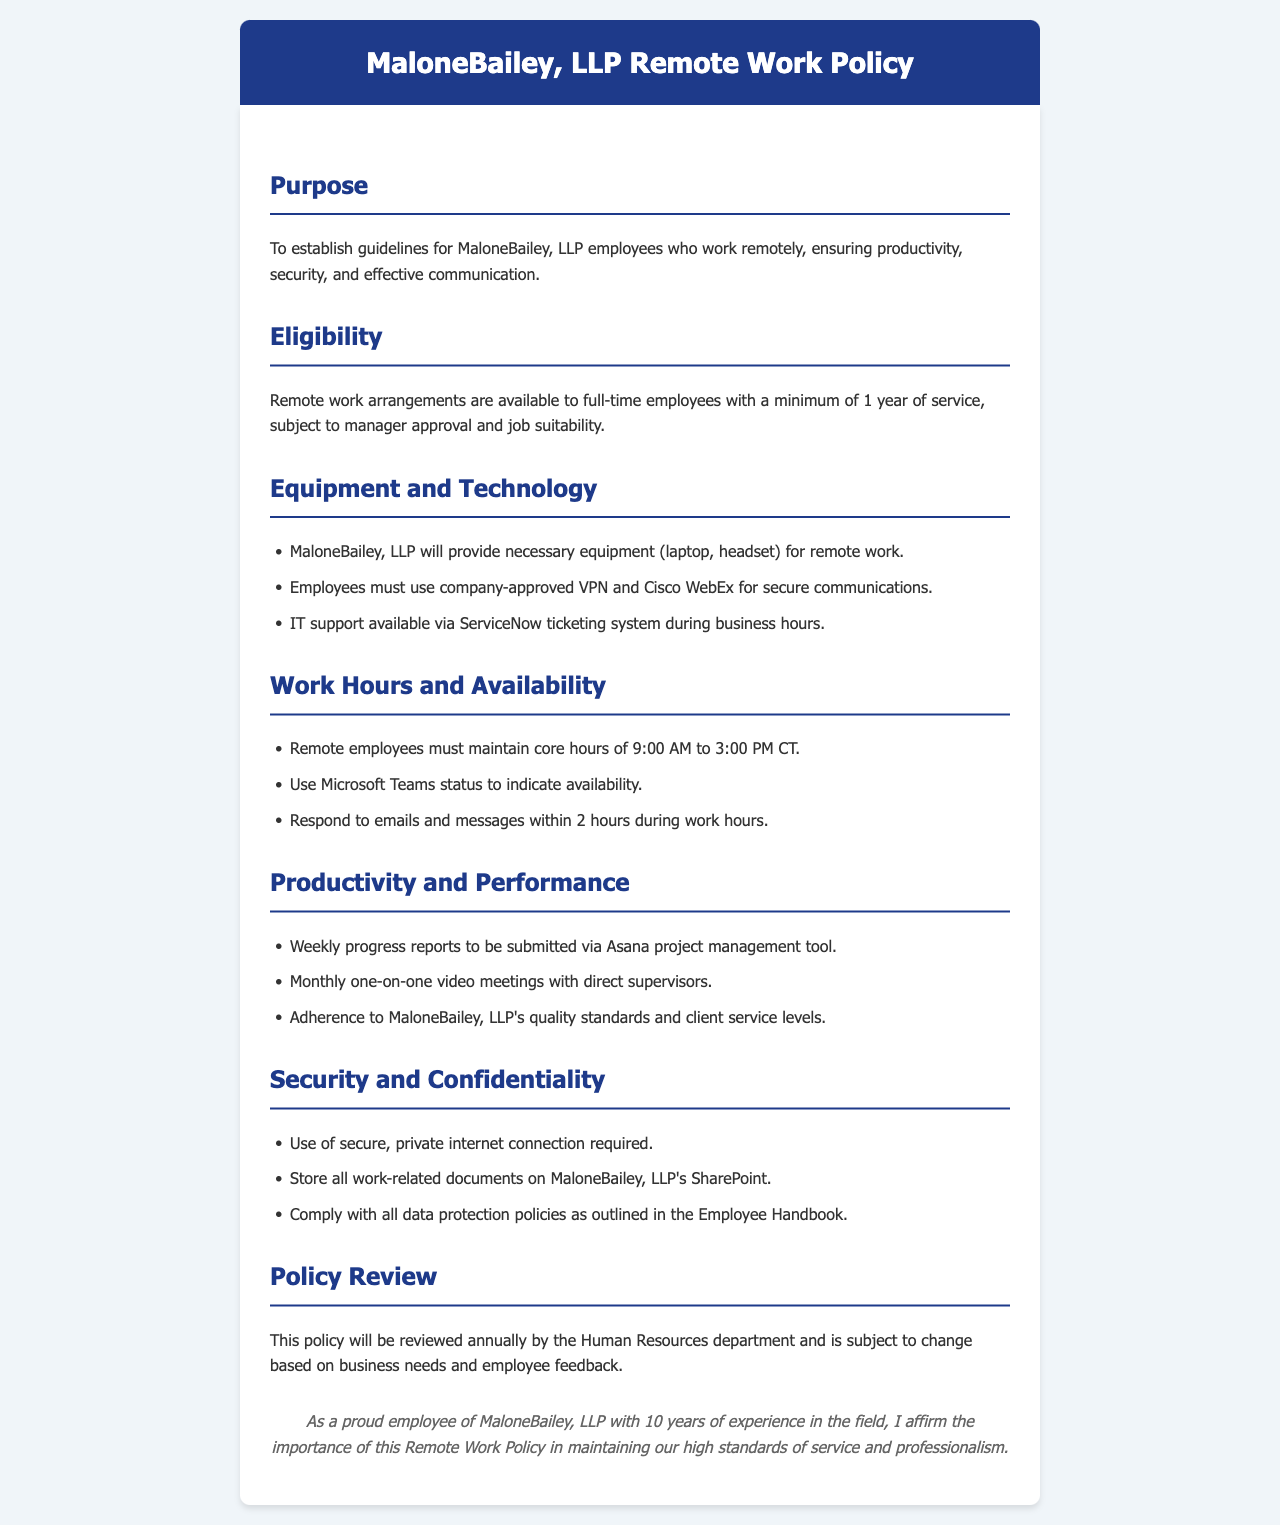What is the minimum service requirement for remote work eligibility? The document states that remote work arrangements are available to full-time employees with a minimum of 1 year of service.
Answer: 1 year Which tools are mentioned for secure communications? The document lists the use of company-approved VPN and Cisco WebEx for secure communications.
Answer: VPN and Cisco WebEx What is the required response time for emails during work hours? The document specifies that employees must respond to emails and messages within 2 hours during work hours.
Answer: 2 hours What must remote employees maintain during core hours? The document indicates that remote employees must maintain availability during core hours of 9:00 AM to 3:00 PM CT.
Answer: Availability How often are progress reports to be submitted? According to the document, weekly progress reports are to be submitted via the Asana project management tool.
Answer: Weekly What is the frequency of one-on-one video meetings with supervisors? The document states that there are monthly one-on-one video meetings with direct supervisors.
Answer: Monthly Where should work-related documents be stored? The document specifies that all work-related documents should be stored on MaloneBailey, LLP's SharePoint.
Answer: SharePoint What aspect of the policy is reviewed annually? The document mentions that the Remote Work Policy will be reviewed annually by the Human Resources department.
Answer: Policy review What is required regarding internet connection security? The document requires the use of a secure, private internet connection for remote work.
Answer: Secure, private internet connection 